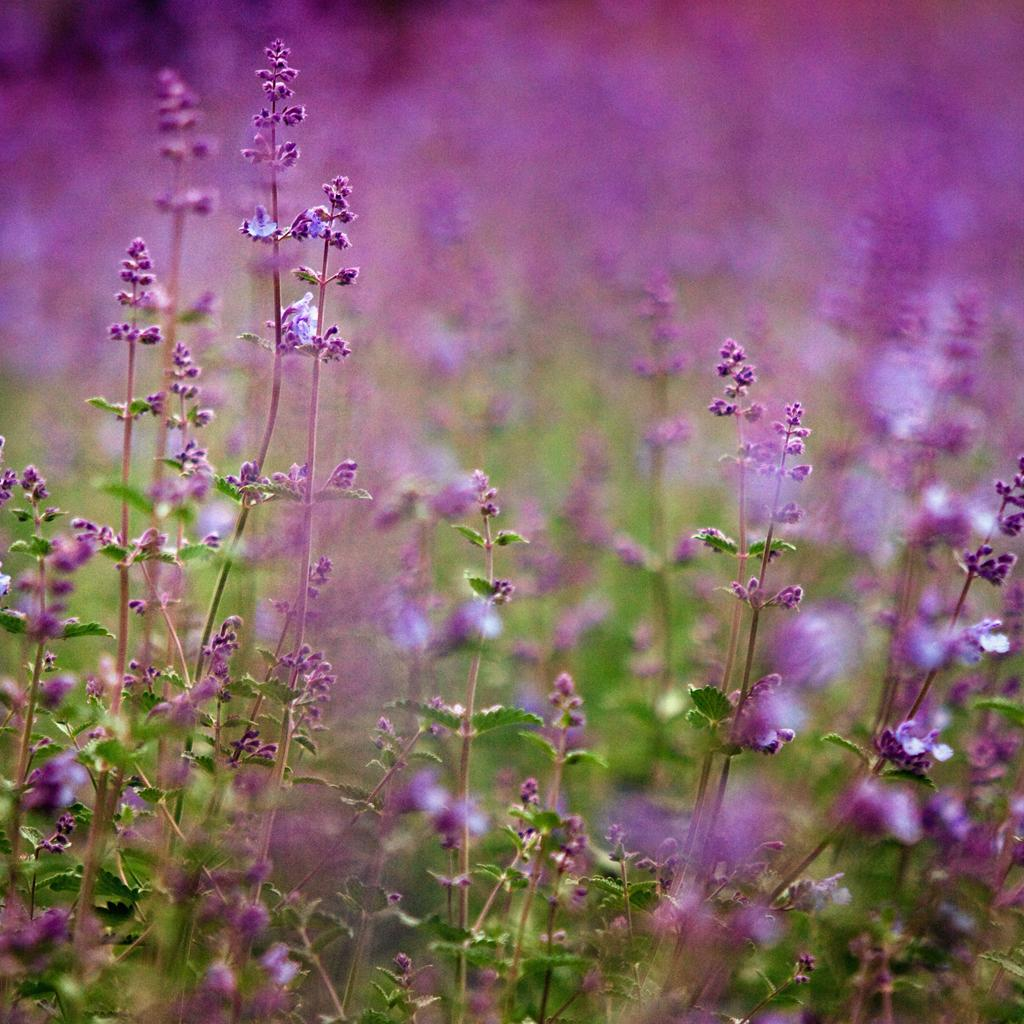What type of plant is featured in the image? There is an English lavender in the image. What type of plantation is depicted in the image? There is no plantation present in the image; it features a single English lavender plant. Who is the representative of the English lavender in the image? There is no representative present in the image, as it is a photograph of a plant and not a person or event. 